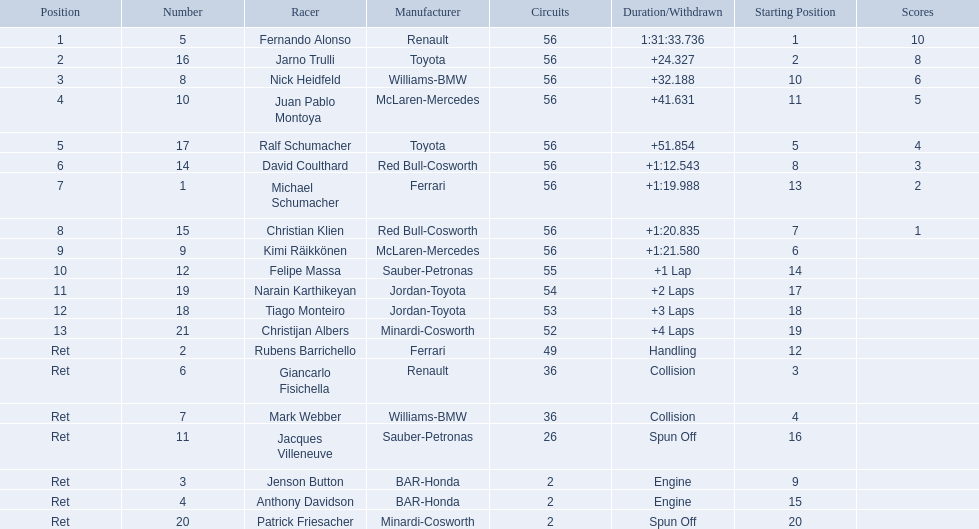What place did fernando alonso finish? 1. How long did it take alonso to finish the race? 1:31:33.736. 